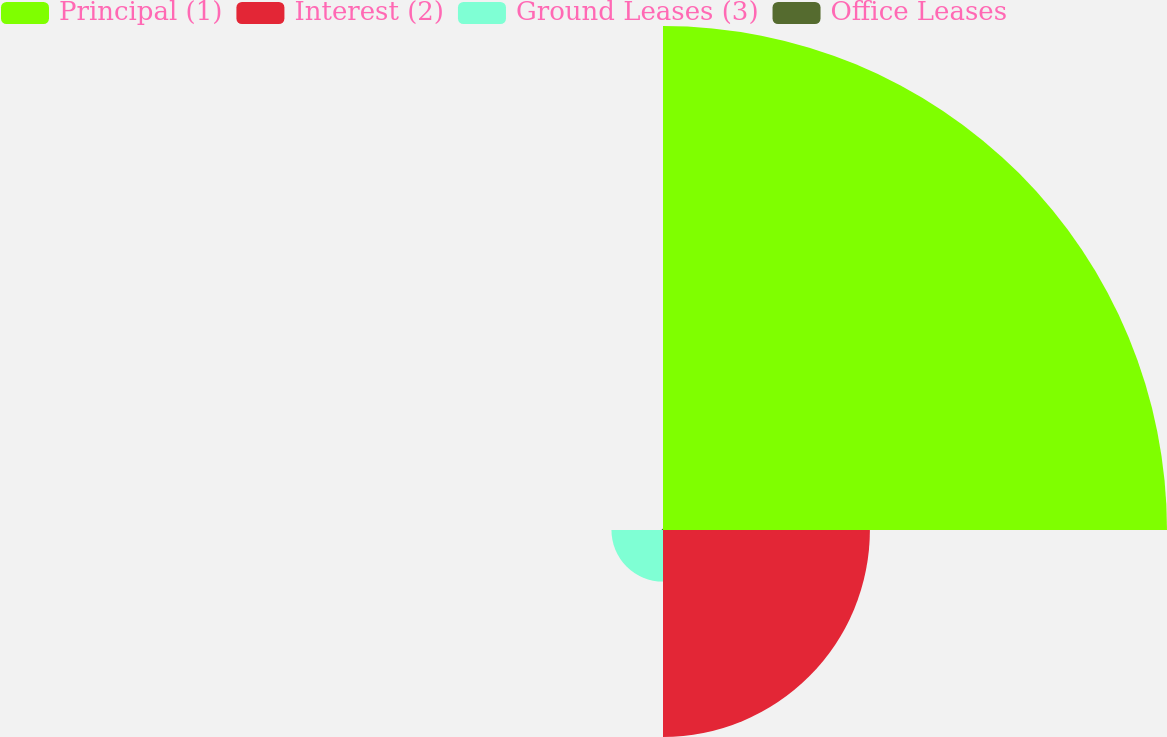<chart> <loc_0><loc_0><loc_500><loc_500><pie_chart><fcel>Principal (1)<fcel>Interest (2)<fcel>Ground Leases (3)<fcel>Office Leases<nl><fcel>65.99%<fcel>27.09%<fcel>6.75%<fcel>0.17%<nl></chart> 